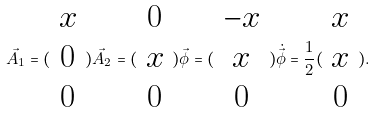Convert formula to latex. <formula><loc_0><loc_0><loc_500><loc_500>\vec { A _ { 1 } } = ( \begin{array} { c } x \\ 0 \\ 0 \end{array} ) \vec { A _ { 2 } } = ( \begin{array} { c } 0 \\ x \\ 0 \end{array} ) \vec { \phi } = ( \begin{array} { c } - x \\ x \\ 0 \end{array} ) \dot { \vec { \phi } } = \frac { 1 } { 2 } ( \begin{array} { c } x \\ x \\ 0 \end{array} ) .</formula> 